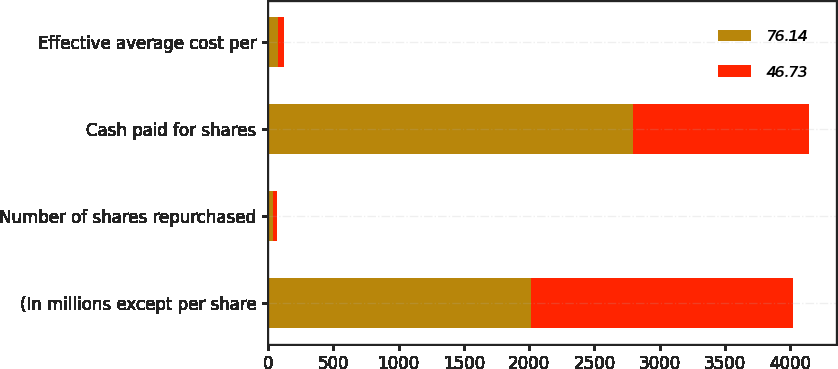Convert chart to OTSL. <chart><loc_0><loc_0><loc_500><loc_500><stacked_bar_chart><ecel><fcel>(In millions except per share<fcel>Number of shares repurchased<fcel>Cash paid for shares<fcel>Effective average cost per<nl><fcel>76.14<fcel>2013<fcel>37<fcel>2793<fcel>76.14<nl><fcel>46.73<fcel>2012<fcel>28<fcel>1350<fcel>46.73<nl></chart> 